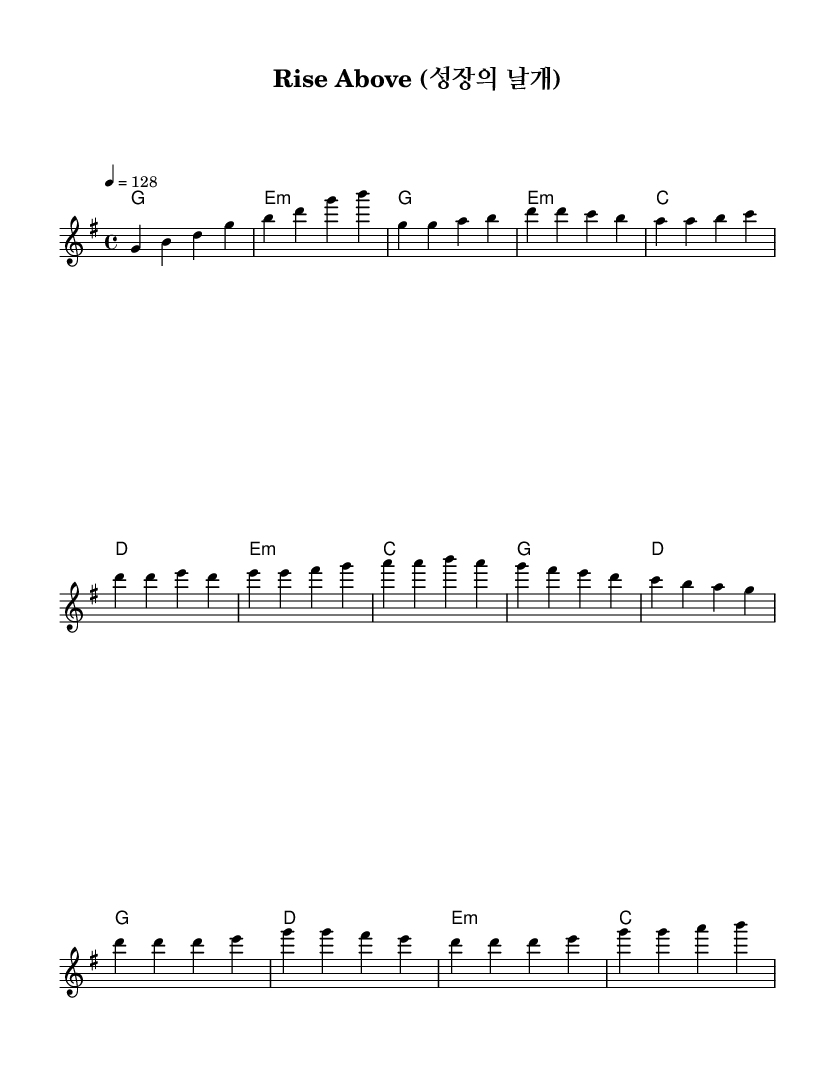What is the key signature of this music? The key signature shown at the beginning of the score indicates G major, which has one sharp (F#).
Answer: G major What is the time signature of this music? The time signature is displayed right after the key signature, shown as 4/4, meaning there are 4 beats per measure.
Answer: 4/4 What is the tempo marking for this piece? The tempo marking in the score indicates the speed at which the piece should be played, specified as 128 beats per minute.
Answer: 128 How many measures are in the chorus section? By analyzing the melody line and counting the measures defined in the chorus, there are four measures found in that section.
Answer: 4 What chords are used in the pre-chorus? The chords listed in the harmonies section during the pre-chorus are E minor, C major, G major, and D major, showing a typical progression for building intensity.
Answer: E minor, C, G, D What mood does the tempo contribute to this K-Pop anthem? The relatively upbeat tempo of 128 BPM gives the piece an energetic and motivating feel, suitable for a motivational anthem focused on personal growth.
Answer: Energetic What is the structure of this piece? The structure can be identified as Intro, Verse 1, Pre-Chorus, and Chorus, which is a common format in K-Pop that supports storytelling and thematic development.
Answer: Intro, Verse 1, Pre-Chorus, Chorus 